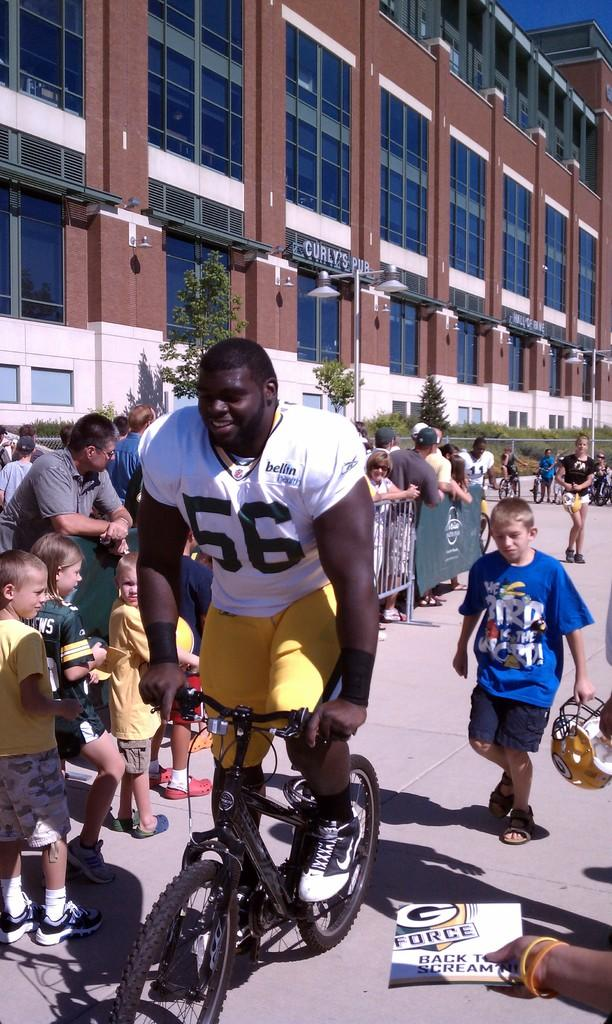How many people are in the image? There is a group of people in the image, but the exact number is not specified. What is one person doing in the image? One person is riding a bicycle in the image. What can be seen in the background of the image? There is a building and a tree in the background of the image. Can you tell me how many carts are being pulled by the lake in the image? There is no lake or carts present in the image. What type of power source is used to move the bicycle in the image? The bicycle in the image is being ridden by a person, so it is powered by human effort, not a separate power source. 